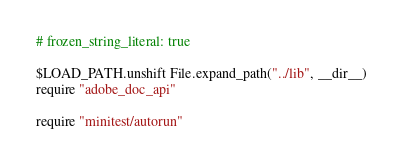Convert code to text. <code><loc_0><loc_0><loc_500><loc_500><_Ruby_># frozen_string_literal: true

$LOAD_PATH.unshift File.expand_path("../lib", __dir__)
require "adobe_doc_api"

require "minitest/autorun"
</code> 